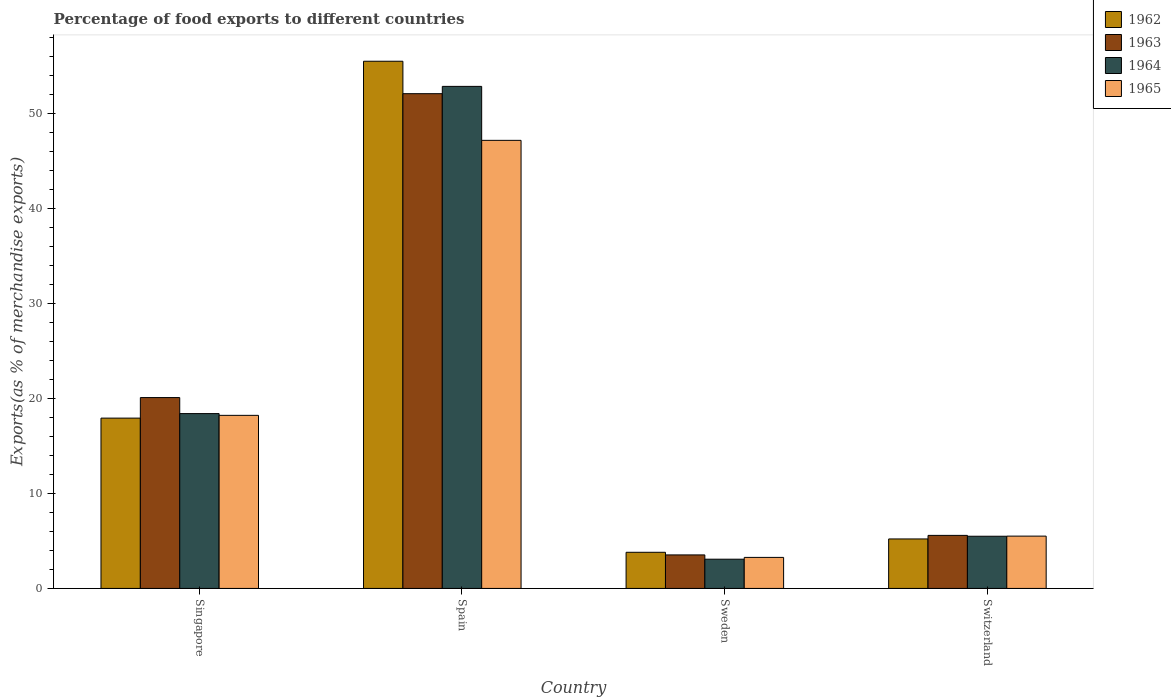How many groups of bars are there?
Your answer should be very brief. 4. What is the label of the 1st group of bars from the left?
Your answer should be very brief. Singapore. In how many cases, is the number of bars for a given country not equal to the number of legend labels?
Your response must be concise. 0. What is the percentage of exports to different countries in 1965 in Switzerland?
Offer a very short reply. 5.51. Across all countries, what is the maximum percentage of exports to different countries in 1965?
Make the answer very short. 47.17. Across all countries, what is the minimum percentage of exports to different countries in 1963?
Ensure brevity in your answer.  3.53. What is the total percentage of exports to different countries in 1964 in the graph?
Offer a very short reply. 79.83. What is the difference between the percentage of exports to different countries in 1963 in Singapore and that in Spain?
Give a very brief answer. -31.99. What is the difference between the percentage of exports to different countries in 1965 in Sweden and the percentage of exports to different countries in 1963 in Spain?
Provide a succinct answer. -48.82. What is the average percentage of exports to different countries in 1962 per country?
Offer a very short reply. 20.61. What is the difference between the percentage of exports to different countries of/in 1964 and percentage of exports to different countries of/in 1962 in Spain?
Your answer should be very brief. -2.65. In how many countries, is the percentage of exports to different countries in 1963 greater than 44 %?
Make the answer very short. 1. What is the ratio of the percentage of exports to different countries in 1964 in Spain to that in Switzerland?
Ensure brevity in your answer.  9.62. Is the difference between the percentage of exports to different countries in 1964 in Sweden and Switzerland greater than the difference between the percentage of exports to different countries in 1962 in Sweden and Switzerland?
Your answer should be very brief. No. What is the difference between the highest and the second highest percentage of exports to different countries in 1964?
Ensure brevity in your answer.  -34.45. What is the difference between the highest and the lowest percentage of exports to different countries in 1965?
Keep it short and to the point. 43.9. In how many countries, is the percentage of exports to different countries in 1964 greater than the average percentage of exports to different countries in 1964 taken over all countries?
Provide a succinct answer. 1. Is the sum of the percentage of exports to different countries in 1964 in Singapore and Sweden greater than the maximum percentage of exports to different countries in 1965 across all countries?
Provide a succinct answer. No. Is it the case that in every country, the sum of the percentage of exports to different countries in 1962 and percentage of exports to different countries in 1963 is greater than the sum of percentage of exports to different countries in 1964 and percentage of exports to different countries in 1965?
Your answer should be very brief. No. What does the 3rd bar from the left in Sweden represents?
Offer a terse response. 1964. Is it the case that in every country, the sum of the percentage of exports to different countries in 1964 and percentage of exports to different countries in 1963 is greater than the percentage of exports to different countries in 1962?
Your answer should be very brief. Yes. How many bars are there?
Provide a short and direct response. 16. How many countries are there in the graph?
Your response must be concise. 4. Does the graph contain any zero values?
Your response must be concise. No. Does the graph contain grids?
Keep it short and to the point. No. How are the legend labels stacked?
Offer a terse response. Vertical. What is the title of the graph?
Your answer should be compact. Percentage of food exports to different countries. Does "1987" appear as one of the legend labels in the graph?
Offer a very short reply. No. What is the label or title of the X-axis?
Give a very brief answer. Country. What is the label or title of the Y-axis?
Offer a terse response. Exports(as % of merchandise exports). What is the Exports(as % of merchandise exports) in 1962 in Singapore?
Provide a short and direct response. 17.93. What is the Exports(as % of merchandise exports) of 1963 in Singapore?
Keep it short and to the point. 20.09. What is the Exports(as % of merchandise exports) in 1964 in Singapore?
Make the answer very short. 18.41. What is the Exports(as % of merchandise exports) in 1965 in Singapore?
Your response must be concise. 18.22. What is the Exports(as % of merchandise exports) of 1962 in Spain?
Your answer should be compact. 55.5. What is the Exports(as % of merchandise exports) in 1963 in Spain?
Provide a short and direct response. 52.09. What is the Exports(as % of merchandise exports) of 1964 in Spain?
Offer a very short reply. 52.85. What is the Exports(as % of merchandise exports) in 1965 in Spain?
Keep it short and to the point. 47.17. What is the Exports(as % of merchandise exports) in 1962 in Sweden?
Give a very brief answer. 3.8. What is the Exports(as % of merchandise exports) in 1963 in Sweden?
Provide a short and direct response. 3.53. What is the Exports(as % of merchandise exports) in 1964 in Sweden?
Offer a very short reply. 3.08. What is the Exports(as % of merchandise exports) of 1965 in Sweden?
Your answer should be very brief. 3.27. What is the Exports(as % of merchandise exports) of 1962 in Switzerland?
Give a very brief answer. 5.21. What is the Exports(as % of merchandise exports) of 1963 in Switzerland?
Your answer should be compact. 5.59. What is the Exports(as % of merchandise exports) of 1964 in Switzerland?
Your response must be concise. 5.49. What is the Exports(as % of merchandise exports) of 1965 in Switzerland?
Give a very brief answer. 5.51. Across all countries, what is the maximum Exports(as % of merchandise exports) in 1962?
Provide a short and direct response. 55.5. Across all countries, what is the maximum Exports(as % of merchandise exports) of 1963?
Your response must be concise. 52.09. Across all countries, what is the maximum Exports(as % of merchandise exports) in 1964?
Keep it short and to the point. 52.85. Across all countries, what is the maximum Exports(as % of merchandise exports) in 1965?
Your answer should be compact. 47.17. Across all countries, what is the minimum Exports(as % of merchandise exports) in 1962?
Ensure brevity in your answer.  3.8. Across all countries, what is the minimum Exports(as % of merchandise exports) of 1963?
Provide a short and direct response. 3.53. Across all countries, what is the minimum Exports(as % of merchandise exports) in 1964?
Offer a terse response. 3.08. Across all countries, what is the minimum Exports(as % of merchandise exports) in 1965?
Your answer should be very brief. 3.27. What is the total Exports(as % of merchandise exports) of 1962 in the graph?
Offer a very short reply. 82.44. What is the total Exports(as % of merchandise exports) of 1963 in the graph?
Keep it short and to the point. 81.29. What is the total Exports(as % of merchandise exports) in 1964 in the graph?
Provide a short and direct response. 79.83. What is the total Exports(as % of merchandise exports) in 1965 in the graph?
Offer a very short reply. 74.17. What is the difference between the Exports(as % of merchandise exports) of 1962 in Singapore and that in Spain?
Keep it short and to the point. -37.57. What is the difference between the Exports(as % of merchandise exports) in 1963 in Singapore and that in Spain?
Offer a terse response. -31.99. What is the difference between the Exports(as % of merchandise exports) in 1964 in Singapore and that in Spain?
Your answer should be compact. -34.45. What is the difference between the Exports(as % of merchandise exports) in 1965 in Singapore and that in Spain?
Ensure brevity in your answer.  -28.95. What is the difference between the Exports(as % of merchandise exports) in 1962 in Singapore and that in Sweden?
Keep it short and to the point. 14.13. What is the difference between the Exports(as % of merchandise exports) in 1963 in Singapore and that in Sweden?
Make the answer very short. 16.56. What is the difference between the Exports(as % of merchandise exports) of 1964 in Singapore and that in Sweden?
Give a very brief answer. 15.33. What is the difference between the Exports(as % of merchandise exports) of 1965 in Singapore and that in Sweden?
Provide a succinct answer. 14.95. What is the difference between the Exports(as % of merchandise exports) in 1962 in Singapore and that in Switzerland?
Provide a short and direct response. 12.72. What is the difference between the Exports(as % of merchandise exports) of 1963 in Singapore and that in Switzerland?
Provide a succinct answer. 14.51. What is the difference between the Exports(as % of merchandise exports) in 1964 in Singapore and that in Switzerland?
Your answer should be very brief. 12.91. What is the difference between the Exports(as % of merchandise exports) in 1965 in Singapore and that in Switzerland?
Make the answer very short. 12.71. What is the difference between the Exports(as % of merchandise exports) in 1962 in Spain and that in Sweden?
Provide a short and direct response. 51.7. What is the difference between the Exports(as % of merchandise exports) in 1963 in Spain and that in Sweden?
Your answer should be very brief. 48.56. What is the difference between the Exports(as % of merchandise exports) of 1964 in Spain and that in Sweden?
Your answer should be very brief. 49.77. What is the difference between the Exports(as % of merchandise exports) of 1965 in Spain and that in Sweden?
Keep it short and to the point. 43.9. What is the difference between the Exports(as % of merchandise exports) of 1962 in Spain and that in Switzerland?
Your response must be concise. 50.29. What is the difference between the Exports(as % of merchandise exports) of 1963 in Spain and that in Switzerland?
Your answer should be compact. 46.5. What is the difference between the Exports(as % of merchandise exports) in 1964 in Spain and that in Switzerland?
Make the answer very short. 47.36. What is the difference between the Exports(as % of merchandise exports) of 1965 in Spain and that in Switzerland?
Your answer should be very brief. 41.67. What is the difference between the Exports(as % of merchandise exports) of 1962 in Sweden and that in Switzerland?
Your answer should be very brief. -1.4. What is the difference between the Exports(as % of merchandise exports) in 1963 in Sweden and that in Switzerland?
Give a very brief answer. -2.06. What is the difference between the Exports(as % of merchandise exports) of 1964 in Sweden and that in Switzerland?
Provide a succinct answer. -2.41. What is the difference between the Exports(as % of merchandise exports) of 1965 in Sweden and that in Switzerland?
Give a very brief answer. -2.24. What is the difference between the Exports(as % of merchandise exports) in 1962 in Singapore and the Exports(as % of merchandise exports) in 1963 in Spain?
Your answer should be very brief. -34.16. What is the difference between the Exports(as % of merchandise exports) of 1962 in Singapore and the Exports(as % of merchandise exports) of 1964 in Spain?
Give a very brief answer. -34.92. What is the difference between the Exports(as % of merchandise exports) in 1962 in Singapore and the Exports(as % of merchandise exports) in 1965 in Spain?
Keep it short and to the point. -29.24. What is the difference between the Exports(as % of merchandise exports) in 1963 in Singapore and the Exports(as % of merchandise exports) in 1964 in Spain?
Offer a terse response. -32.76. What is the difference between the Exports(as % of merchandise exports) in 1963 in Singapore and the Exports(as % of merchandise exports) in 1965 in Spain?
Offer a very short reply. -27.08. What is the difference between the Exports(as % of merchandise exports) of 1964 in Singapore and the Exports(as % of merchandise exports) of 1965 in Spain?
Provide a succinct answer. -28.77. What is the difference between the Exports(as % of merchandise exports) of 1962 in Singapore and the Exports(as % of merchandise exports) of 1963 in Sweden?
Make the answer very short. 14.4. What is the difference between the Exports(as % of merchandise exports) of 1962 in Singapore and the Exports(as % of merchandise exports) of 1964 in Sweden?
Provide a succinct answer. 14.85. What is the difference between the Exports(as % of merchandise exports) in 1962 in Singapore and the Exports(as % of merchandise exports) in 1965 in Sweden?
Give a very brief answer. 14.66. What is the difference between the Exports(as % of merchandise exports) in 1963 in Singapore and the Exports(as % of merchandise exports) in 1964 in Sweden?
Provide a short and direct response. 17.01. What is the difference between the Exports(as % of merchandise exports) of 1963 in Singapore and the Exports(as % of merchandise exports) of 1965 in Sweden?
Make the answer very short. 16.83. What is the difference between the Exports(as % of merchandise exports) in 1964 in Singapore and the Exports(as % of merchandise exports) in 1965 in Sweden?
Provide a succinct answer. 15.14. What is the difference between the Exports(as % of merchandise exports) in 1962 in Singapore and the Exports(as % of merchandise exports) in 1963 in Switzerland?
Make the answer very short. 12.34. What is the difference between the Exports(as % of merchandise exports) of 1962 in Singapore and the Exports(as % of merchandise exports) of 1964 in Switzerland?
Ensure brevity in your answer.  12.44. What is the difference between the Exports(as % of merchandise exports) of 1962 in Singapore and the Exports(as % of merchandise exports) of 1965 in Switzerland?
Offer a terse response. 12.42. What is the difference between the Exports(as % of merchandise exports) in 1963 in Singapore and the Exports(as % of merchandise exports) in 1964 in Switzerland?
Offer a very short reply. 14.6. What is the difference between the Exports(as % of merchandise exports) in 1963 in Singapore and the Exports(as % of merchandise exports) in 1965 in Switzerland?
Make the answer very short. 14.59. What is the difference between the Exports(as % of merchandise exports) in 1964 in Singapore and the Exports(as % of merchandise exports) in 1965 in Switzerland?
Your response must be concise. 12.9. What is the difference between the Exports(as % of merchandise exports) of 1962 in Spain and the Exports(as % of merchandise exports) of 1963 in Sweden?
Keep it short and to the point. 51.97. What is the difference between the Exports(as % of merchandise exports) of 1962 in Spain and the Exports(as % of merchandise exports) of 1964 in Sweden?
Make the answer very short. 52.42. What is the difference between the Exports(as % of merchandise exports) in 1962 in Spain and the Exports(as % of merchandise exports) in 1965 in Sweden?
Keep it short and to the point. 52.23. What is the difference between the Exports(as % of merchandise exports) in 1963 in Spain and the Exports(as % of merchandise exports) in 1964 in Sweden?
Provide a succinct answer. 49.01. What is the difference between the Exports(as % of merchandise exports) of 1963 in Spain and the Exports(as % of merchandise exports) of 1965 in Sweden?
Ensure brevity in your answer.  48.82. What is the difference between the Exports(as % of merchandise exports) of 1964 in Spain and the Exports(as % of merchandise exports) of 1965 in Sweden?
Provide a short and direct response. 49.58. What is the difference between the Exports(as % of merchandise exports) of 1962 in Spain and the Exports(as % of merchandise exports) of 1963 in Switzerland?
Ensure brevity in your answer.  49.92. What is the difference between the Exports(as % of merchandise exports) of 1962 in Spain and the Exports(as % of merchandise exports) of 1964 in Switzerland?
Offer a very short reply. 50.01. What is the difference between the Exports(as % of merchandise exports) in 1962 in Spain and the Exports(as % of merchandise exports) in 1965 in Switzerland?
Give a very brief answer. 49.99. What is the difference between the Exports(as % of merchandise exports) in 1963 in Spain and the Exports(as % of merchandise exports) in 1964 in Switzerland?
Your answer should be compact. 46.59. What is the difference between the Exports(as % of merchandise exports) of 1963 in Spain and the Exports(as % of merchandise exports) of 1965 in Switzerland?
Your answer should be compact. 46.58. What is the difference between the Exports(as % of merchandise exports) of 1964 in Spain and the Exports(as % of merchandise exports) of 1965 in Switzerland?
Make the answer very short. 47.35. What is the difference between the Exports(as % of merchandise exports) in 1962 in Sweden and the Exports(as % of merchandise exports) in 1963 in Switzerland?
Your response must be concise. -1.78. What is the difference between the Exports(as % of merchandise exports) in 1962 in Sweden and the Exports(as % of merchandise exports) in 1964 in Switzerland?
Your response must be concise. -1.69. What is the difference between the Exports(as % of merchandise exports) of 1962 in Sweden and the Exports(as % of merchandise exports) of 1965 in Switzerland?
Provide a short and direct response. -1.7. What is the difference between the Exports(as % of merchandise exports) of 1963 in Sweden and the Exports(as % of merchandise exports) of 1964 in Switzerland?
Ensure brevity in your answer.  -1.96. What is the difference between the Exports(as % of merchandise exports) of 1963 in Sweden and the Exports(as % of merchandise exports) of 1965 in Switzerland?
Your answer should be compact. -1.98. What is the difference between the Exports(as % of merchandise exports) in 1964 in Sweden and the Exports(as % of merchandise exports) in 1965 in Switzerland?
Offer a terse response. -2.43. What is the average Exports(as % of merchandise exports) in 1962 per country?
Your answer should be compact. 20.61. What is the average Exports(as % of merchandise exports) of 1963 per country?
Your answer should be very brief. 20.32. What is the average Exports(as % of merchandise exports) of 1964 per country?
Provide a short and direct response. 19.96. What is the average Exports(as % of merchandise exports) of 1965 per country?
Your answer should be very brief. 18.54. What is the difference between the Exports(as % of merchandise exports) in 1962 and Exports(as % of merchandise exports) in 1963 in Singapore?
Keep it short and to the point. -2.16. What is the difference between the Exports(as % of merchandise exports) of 1962 and Exports(as % of merchandise exports) of 1964 in Singapore?
Your answer should be very brief. -0.48. What is the difference between the Exports(as % of merchandise exports) in 1962 and Exports(as % of merchandise exports) in 1965 in Singapore?
Your answer should be very brief. -0.29. What is the difference between the Exports(as % of merchandise exports) in 1963 and Exports(as % of merchandise exports) in 1964 in Singapore?
Ensure brevity in your answer.  1.69. What is the difference between the Exports(as % of merchandise exports) of 1963 and Exports(as % of merchandise exports) of 1965 in Singapore?
Give a very brief answer. 1.87. What is the difference between the Exports(as % of merchandise exports) of 1964 and Exports(as % of merchandise exports) of 1965 in Singapore?
Your answer should be compact. 0.18. What is the difference between the Exports(as % of merchandise exports) of 1962 and Exports(as % of merchandise exports) of 1963 in Spain?
Make the answer very short. 3.42. What is the difference between the Exports(as % of merchandise exports) of 1962 and Exports(as % of merchandise exports) of 1964 in Spain?
Your answer should be very brief. 2.65. What is the difference between the Exports(as % of merchandise exports) in 1962 and Exports(as % of merchandise exports) in 1965 in Spain?
Offer a very short reply. 8.33. What is the difference between the Exports(as % of merchandise exports) in 1963 and Exports(as % of merchandise exports) in 1964 in Spain?
Provide a succinct answer. -0.77. What is the difference between the Exports(as % of merchandise exports) in 1963 and Exports(as % of merchandise exports) in 1965 in Spain?
Ensure brevity in your answer.  4.91. What is the difference between the Exports(as % of merchandise exports) in 1964 and Exports(as % of merchandise exports) in 1965 in Spain?
Provide a short and direct response. 5.68. What is the difference between the Exports(as % of merchandise exports) in 1962 and Exports(as % of merchandise exports) in 1963 in Sweden?
Keep it short and to the point. 0.28. What is the difference between the Exports(as % of merchandise exports) of 1962 and Exports(as % of merchandise exports) of 1964 in Sweden?
Keep it short and to the point. 0.73. What is the difference between the Exports(as % of merchandise exports) in 1962 and Exports(as % of merchandise exports) in 1965 in Sweden?
Your answer should be very brief. 0.54. What is the difference between the Exports(as % of merchandise exports) of 1963 and Exports(as % of merchandise exports) of 1964 in Sweden?
Offer a terse response. 0.45. What is the difference between the Exports(as % of merchandise exports) in 1963 and Exports(as % of merchandise exports) in 1965 in Sweden?
Give a very brief answer. 0.26. What is the difference between the Exports(as % of merchandise exports) in 1964 and Exports(as % of merchandise exports) in 1965 in Sweden?
Provide a succinct answer. -0.19. What is the difference between the Exports(as % of merchandise exports) in 1962 and Exports(as % of merchandise exports) in 1963 in Switzerland?
Offer a terse response. -0.38. What is the difference between the Exports(as % of merchandise exports) of 1962 and Exports(as % of merchandise exports) of 1964 in Switzerland?
Your answer should be compact. -0.28. What is the difference between the Exports(as % of merchandise exports) of 1962 and Exports(as % of merchandise exports) of 1965 in Switzerland?
Offer a very short reply. -0.3. What is the difference between the Exports(as % of merchandise exports) in 1963 and Exports(as % of merchandise exports) in 1964 in Switzerland?
Your response must be concise. 0.09. What is the difference between the Exports(as % of merchandise exports) of 1963 and Exports(as % of merchandise exports) of 1965 in Switzerland?
Offer a very short reply. 0.08. What is the difference between the Exports(as % of merchandise exports) in 1964 and Exports(as % of merchandise exports) in 1965 in Switzerland?
Provide a short and direct response. -0.01. What is the ratio of the Exports(as % of merchandise exports) of 1962 in Singapore to that in Spain?
Your answer should be very brief. 0.32. What is the ratio of the Exports(as % of merchandise exports) of 1963 in Singapore to that in Spain?
Your answer should be very brief. 0.39. What is the ratio of the Exports(as % of merchandise exports) of 1964 in Singapore to that in Spain?
Your answer should be very brief. 0.35. What is the ratio of the Exports(as % of merchandise exports) of 1965 in Singapore to that in Spain?
Keep it short and to the point. 0.39. What is the ratio of the Exports(as % of merchandise exports) in 1962 in Singapore to that in Sweden?
Your response must be concise. 4.71. What is the ratio of the Exports(as % of merchandise exports) of 1963 in Singapore to that in Sweden?
Your answer should be compact. 5.69. What is the ratio of the Exports(as % of merchandise exports) of 1964 in Singapore to that in Sweden?
Ensure brevity in your answer.  5.98. What is the ratio of the Exports(as % of merchandise exports) in 1965 in Singapore to that in Sweden?
Give a very brief answer. 5.58. What is the ratio of the Exports(as % of merchandise exports) of 1962 in Singapore to that in Switzerland?
Offer a very short reply. 3.44. What is the ratio of the Exports(as % of merchandise exports) in 1963 in Singapore to that in Switzerland?
Your response must be concise. 3.6. What is the ratio of the Exports(as % of merchandise exports) of 1964 in Singapore to that in Switzerland?
Make the answer very short. 3.35. What is the ratio of the Exports(as % of merchandise exports) in 1965 in Singapore to that in Switzerland?
Your response must be concise. 3.31. What is the ratio of the Exports(as % of merchandise exports) of 1962 in Spain to that in Sweden?
Keep it short and to the point. 14.59. What is the ratio of the Exports(as % of merchandise exports) of 1963 in Spain to that in Sweden?
Offer a very short reply. 14.76. What is the ratio of the Exports(as % of merchandise exports) of 1964 in Spain to that in Sweden?
Keep it short and to the point. 17.17. What is the ratio of the Exports(as % of merchandise exports) of 1965 in Spain to that in Sweden?
Provide a short and direct response. 14.44. What is the ratio of the Exports(as % of merchandise exports) of 1962 in Spain to that in Switzerland?
Offer a terse response. 10.65. What is the ratio of the Exports(as % of merchandise exports) in 1963 in Spain to that in Switzerland?
Your answer should be very brief. 9.33. What is the ratio of the Exports(as % of merchandise exports) of 1964 in Spain to that in Switzerland?
Keep it short and to the point. 9.62. What is the ratio of the Exports(as % of merchandise exports) of 1965 in Spain to that in Switzerland?
Offer a very short reply. 8.57. What is the ratio of the Exports(as % of merchandise exports) of 1962 in Sweden to that in Switzerland?
Your answer should be very brief. 0.73. What is the ratio of the Exports(as % of merchandise exports) of 1963 in Sweden to that in Switzerland?
Offer a very short reply. 0.63. What is the ratio of the Exports(as % of merchandise exports) of 1964 in Sweden to that in Switzerland?
Offer a terse response. 0.56. What is the ratio of the Exports(as % of merchandise exports) in 1965 in Sweden to that in Switzerland?
Give a very brief answer. 0.59. What is the difference between the highest and the second highest Exports(as % of merchandise exports) in 1962?
Your response must be concise. 37.57. What is the difference between the highest and the second highest Exports(as % of merchandise exports) in 1963?
Your answer should be very brief. 31.99. What is the difference between the highest and the second highest Exports(as % of merchandise exports) in 1964?
Your answer should be very brief. 34.45. What is the difference between the highest and the second highest Exports(as % of merchandise exports) of 1965?
Ensure brevity in your answer.  28.95. What is the difference between the highest and the lowest Exports(as % of merchandise exports) of 1962?
Provide a succinct answer. 51.7. What is the difference between the highest and the lowest Exports(as % of merchandise exports) in 1963?
Offer a very short reply. 48.56. What is the difference between the highest and the lowest Exports(as % of merchandise exports) of 1964?
Offer a terse response. 49.77. What is the difference between the highest and the lowest Exports(as % of merchandise exports) of 1965?
Provide a succinct answer. 43.9. 